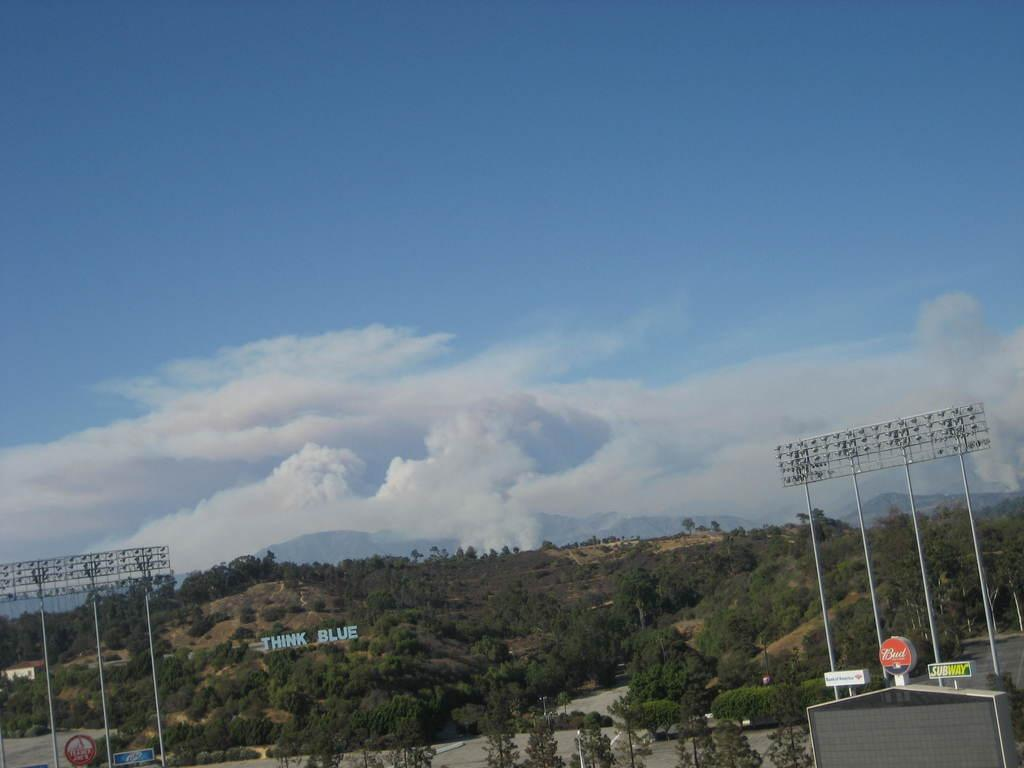What is located in the foreground of the picture? In the foreground of the picture, there are flood lights, trees, hoardings, and a nameplate. Can you describe the sky in the image? The sky is visible in the image and is slightly cloudy. What can be seen in the center of the background of the image? There are mountains in the center of the background of the image. How many geese are flying over the mountains in the image? There are no geese present in the image; it only features flood lights, trees, hoardings, a nameplate, and mountains. What color is the eye of the person in the image? There is no person present in the image, so it is not possible to determine the color of their eye. 